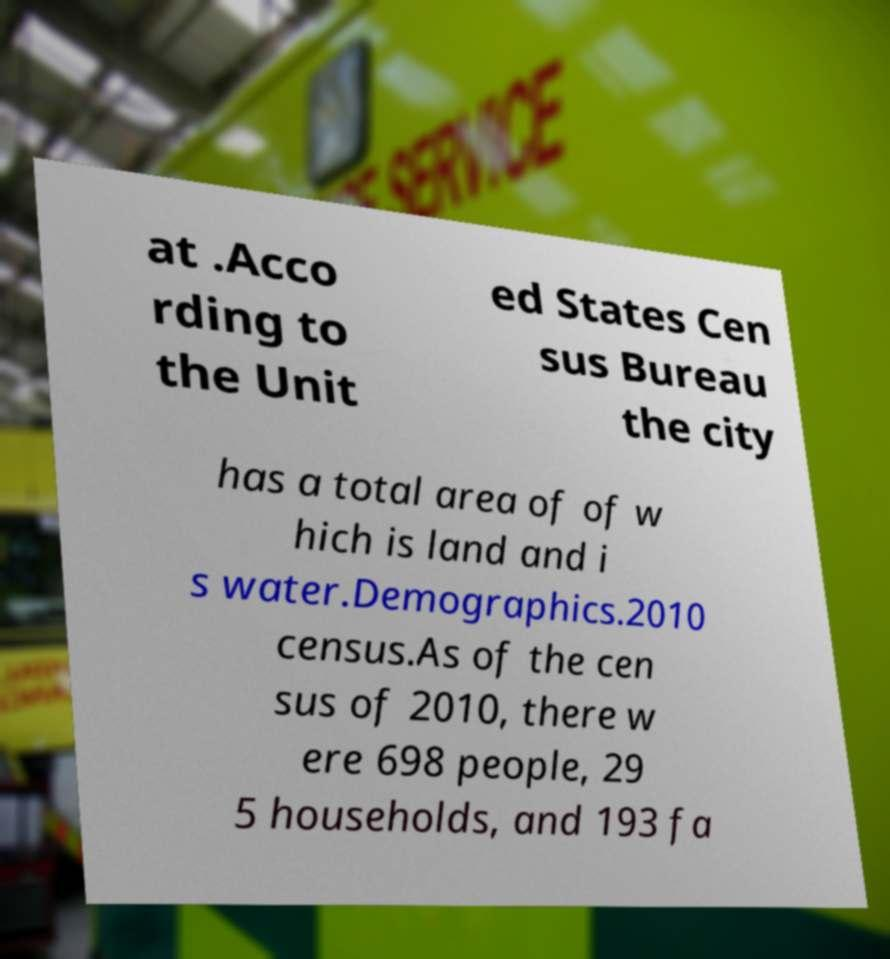Please identify and transcribe the text found in this image. at .Acco rding to the Unit ed States Cen sus Bureau the city has a total area of of w hich is land and i s water.Demographics.2010 census.As of the cen sus of 2010, there w ere 698 people, 29 5 households, and 193 fa 